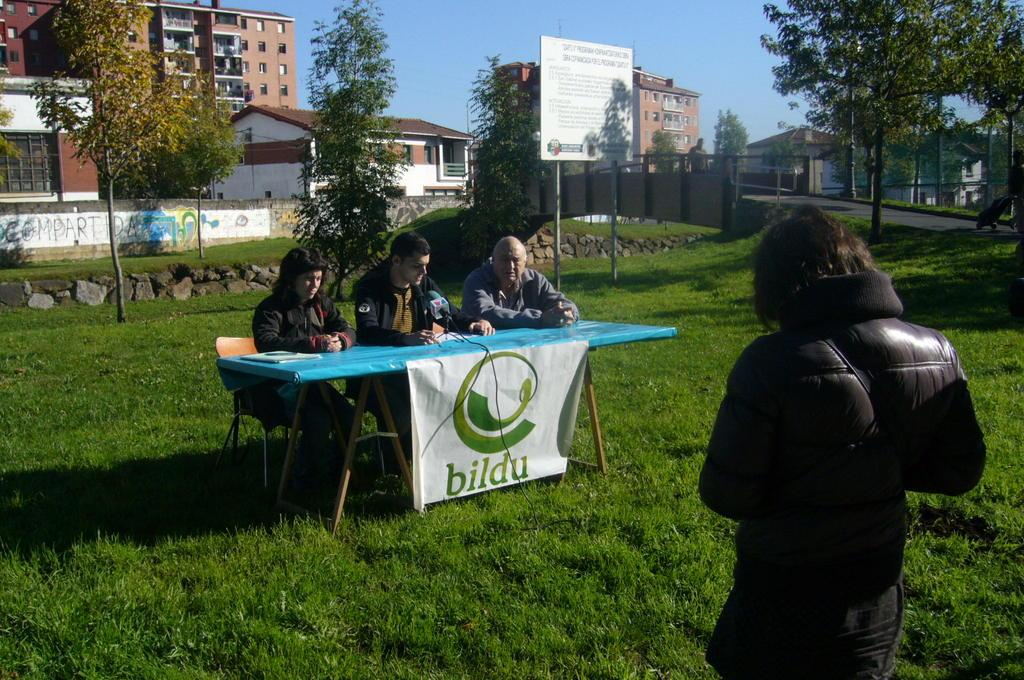<image>
Render a clear and concise summary of the photo. Woman standing in front of a table that has a sign saying BILDU. 